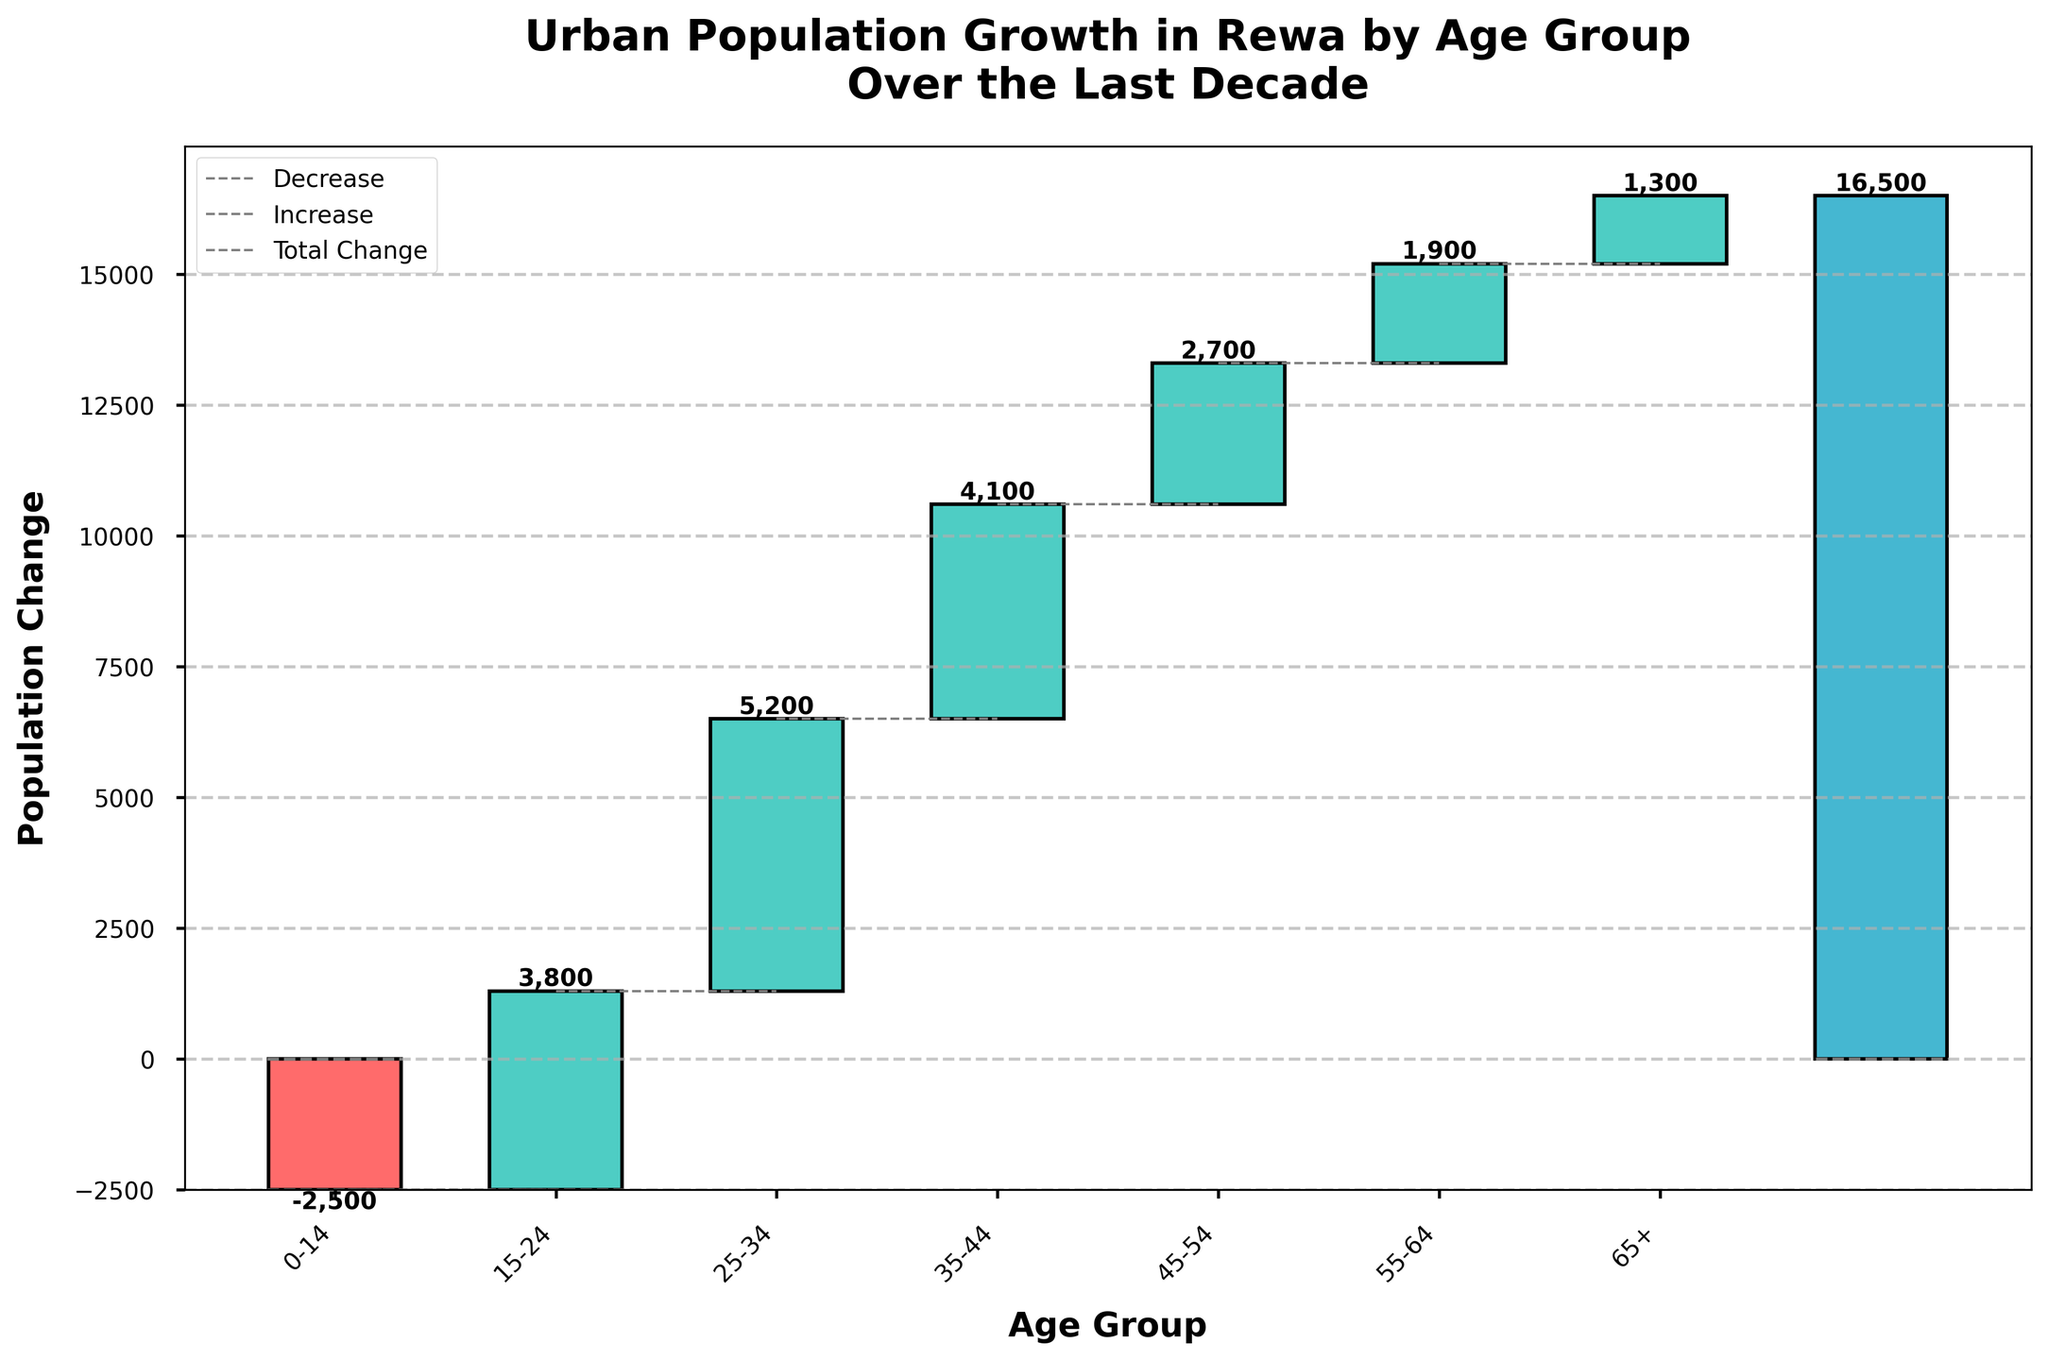What is the title of the figure? The title of the figure is usually found at the top and summarizes the figure's main point. The title here is "Urban Population Growth in Rewa by Age Group Over the Last Decade".
Answer: Urban Population Growth in Rewa by Age Group Over the Last Decade Which age group experienced the largest increase in population? To find this, look for the tallest green bar. The 25-34 age group has the highest positive change.
Answer: 25-34 How much did the population in the 0-14 age group change? The bar for the 0-14 age group is at the far left and has a negative change. The figure attached to this bar is -2500.
Answer: -2500 What is the total population change over the last decade? The total population change is represented by the bar at the far right. This bar shows the final cumulative change which is 16500.
Answer: 16500 Which age groups experienced a decrease in population? Identify the red bars as they represent a decrease. The 0-14 age group has a red bar illustrating a decrease in population.
Answer: 0-14 What is the combined population change for the 35-44 and 45-54 age groups? Add the changes from the bars representing the 35-44 and 45-54 age groups: 4100 + 2700.
Answer: 6800 Which age group had a smaller population increase, 55-64 or 65+? Compare the heights of the green bars for the 55-64 and 65+ age groups. The 65+ age group has a smaller increase of 1300 compared to 1900 for the 55-64 age group.
Answer: 65+ How does the population change in the 15-24 age group compare to the 25-34 age group? Compare the values represented by the bars for 15-24 (3800) and 25-34 (5200). The 25-34 age group has a higher increase in population than the 15-24 age group.
Answer: 25-34 is higher How is the trend of population change different between younger (0-14) and older (65+) age groups? Identify the changes for the youngest and oldest age groups: 0-14 shows −2500 (a decline), while 65+ shows +1300 (an increase), indicating a contrasting trend.
Answer: Younger declines, older increases 